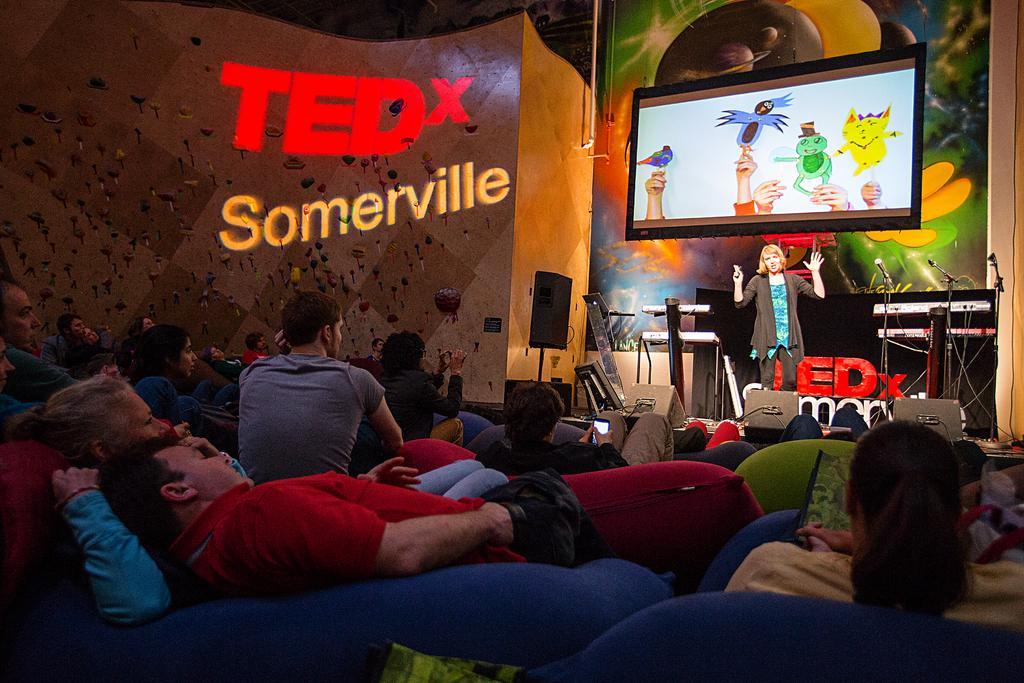Describe this image in one or two sentences. As we can see in the image there is a wall, screen, few people, sofas, sound box and the woman standing over here is wearing black color jacket. 